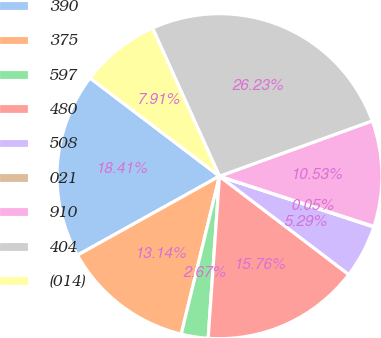Convert chart to OTSL. <chart><loc_0><loc_0><loc_500><loc_500><pie_chart><fcel>390<fcel>375<fcel>597<fcel>480<fcel>508<fcel>021<fcel>910<fcel>404<fcel>(014)<nl><fcel>18.41%<fcel>13.14%<fcel>2.67%<fcel>15.76%<fcel>5.29%<fcel>0.05%<fcel>10.53%<fcel>26.23%<fcel>7.91%<nl></chart> 